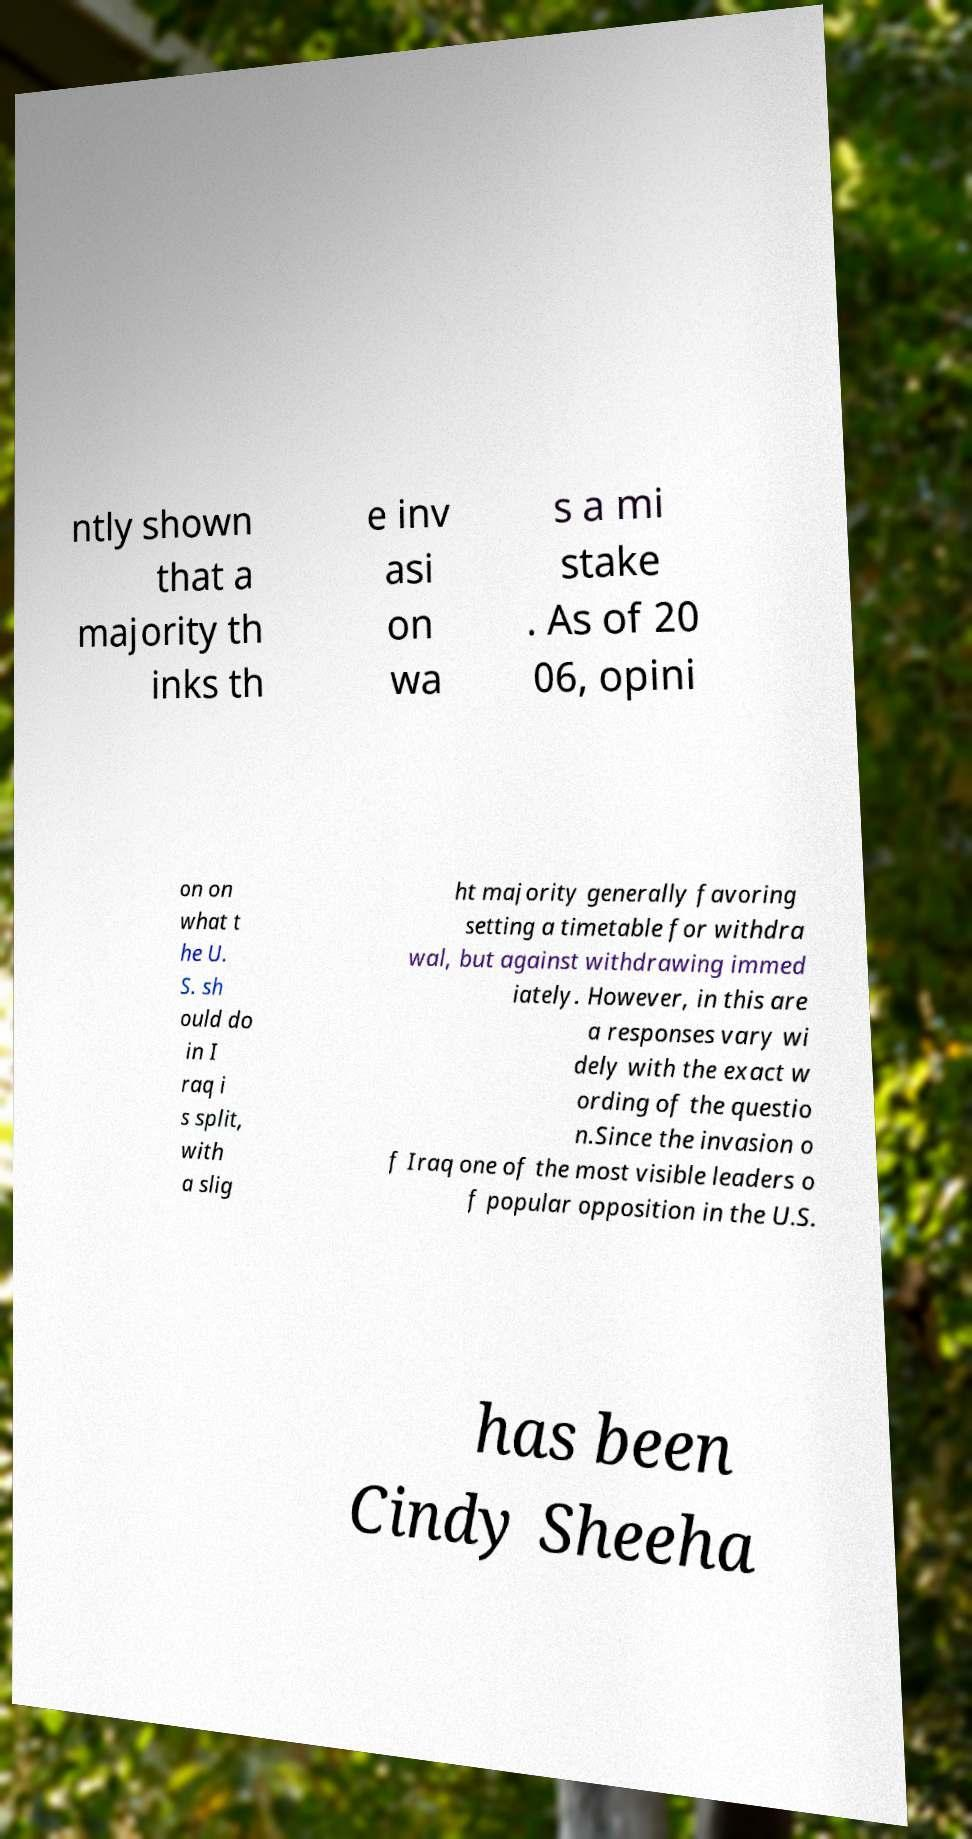There's text embedded in this image that I need extracted. Can you transcribe it verbatim? ntly shown that a majority th inks th e inv asi on wa s a mi stake . As of 20 06, opini on on what t he U. S. sh ould do in I raq i s split, with a slig ht majority generally favoring setting a timetable for withdra wal, but against withdrawing immed iately. However, in this are a responses vary wi dely with the exact w ording of the questio n.Since the invasion o f Iraq one of the most visible leaders o f popular opposition in the U.S. has been Cindy Sheeha 